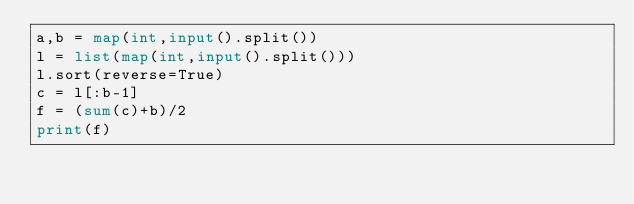<code> <loc_0><loc_0><loc_500><loc_500><_Python_>a,b = map(int,input().split())
l = list(map(int,input().split()))
l.sort(reverse=True)
c = l[:b-1]
f = (sum(c)+b)/2
print(f)</code> 